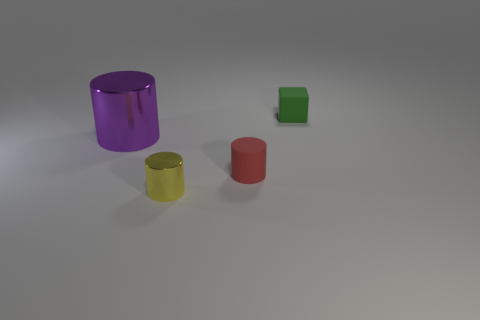Add 2 tiny matte cubes. How many objects exist? 6 Subtract all cylinders. How many objects are left? 1 Subtract 1 yellow cylinders. How many objects are left? 3 Subtract all tiny brown rubber things. Subtract all yellow cylinders. How many objects are left? 3 Add 1 large metallic cylinders. How many large metallic cylinders are left? 2 Add 2 purple objects. How many purple objects exist? 3 